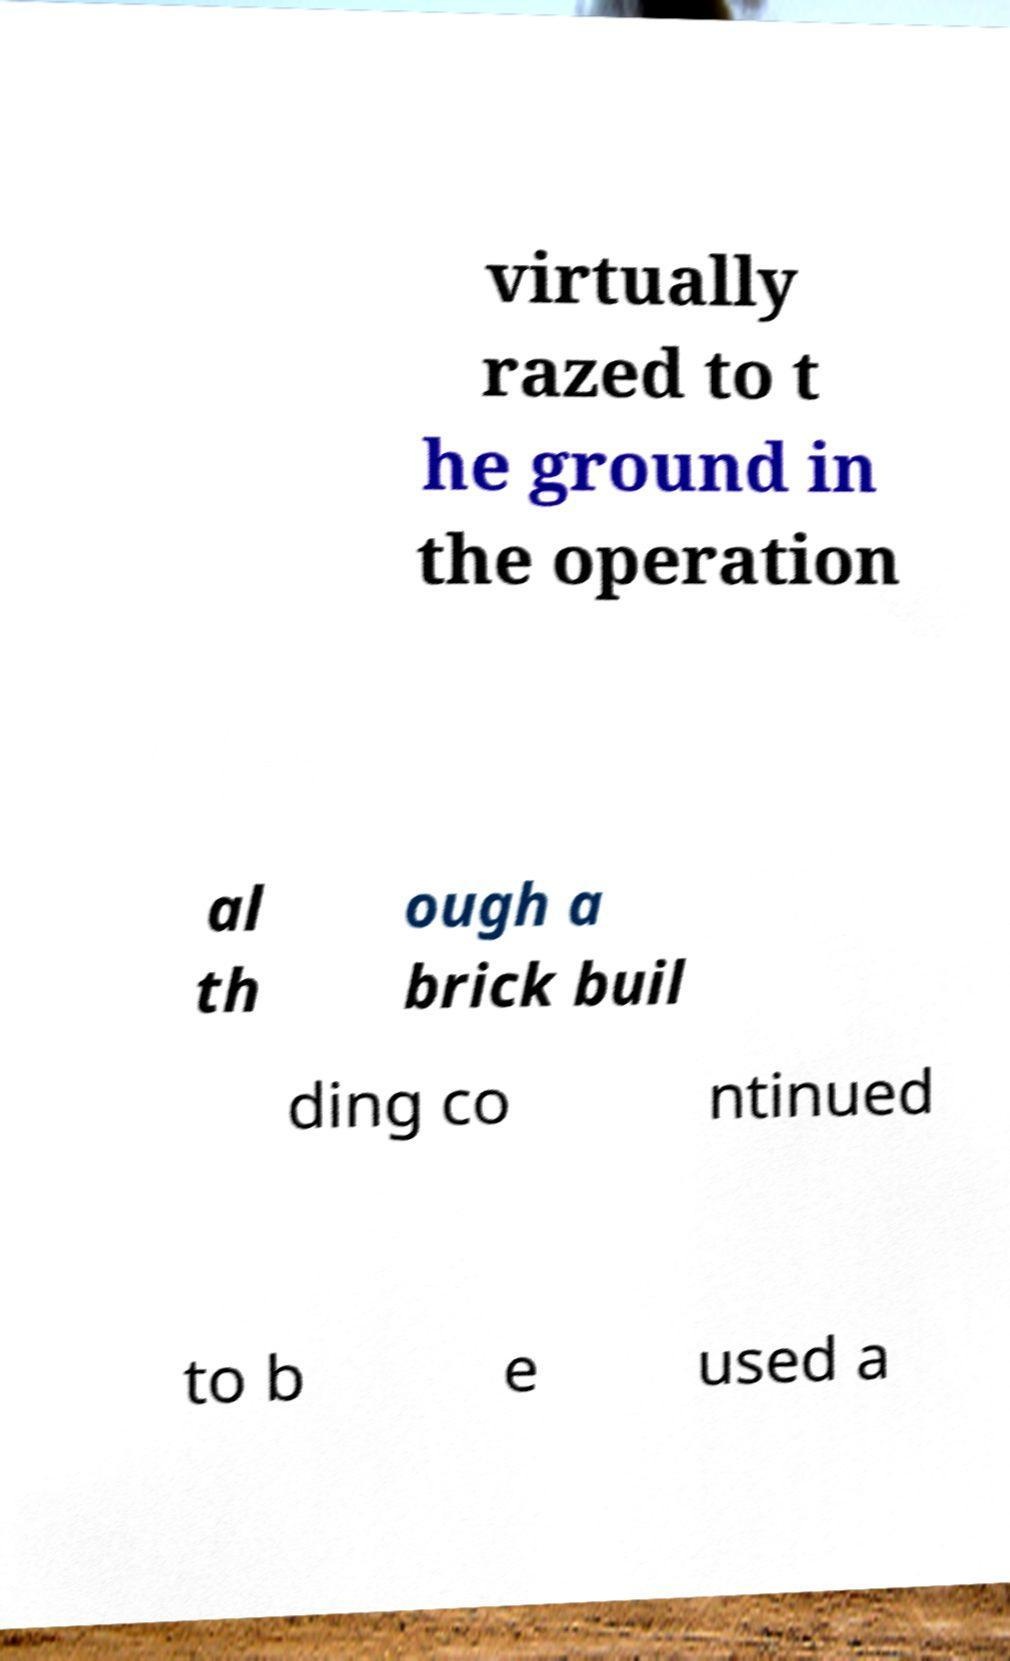Please identify and transcribe the text found in this image. virtually razed to t he ground in the operation al th ough a brick buil ding co ntinued to b e used a 